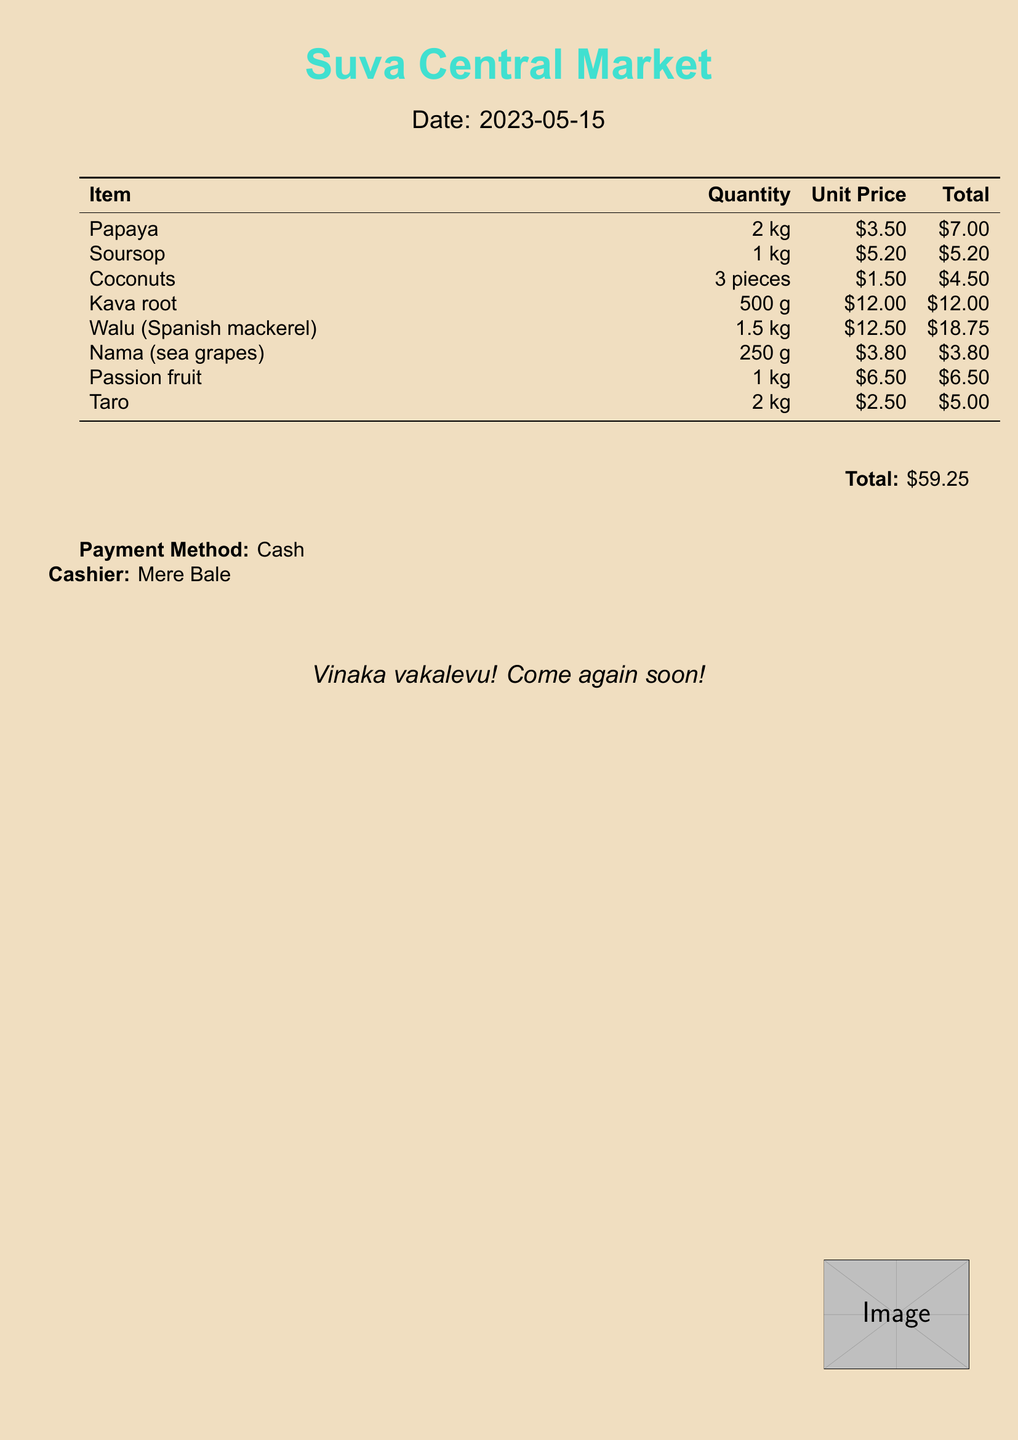What is the date of the receipt? The date can be found at the top of the document, it is provided under "Date:"
Answer: 2023-05-15 How many pieces of coconuts were purchased? The quantity of coconuts is listed in the table under "Quantity" for the item "Coconuts"
Answer: 3 pieces What is the unit price of kava root? The unit price for kava root can be found in the corresponding row in the table under "Unit Price"
Answer: $12.00 What is the total amount spent on all items? The total is indicated at the bottom of the document under "Total:"
Answer: $59.25 Who is the cashier for the transaction? The cashier's name is noted towards the end of the document under "Cashier:"
Answer: Mere Bale What tropical fruit has a total cost of $7.00? This information is available in the table under the item that corresponds to this total
Answer: Papaya What seafood item was purchased? The document lists several items, and we can identify the seafood item from the table
Answer: Walu (Spanish mackerel) What is the total price for the soursop? The total price for soursop can be found next to it in the table under "Total"
Answer: $5.20 